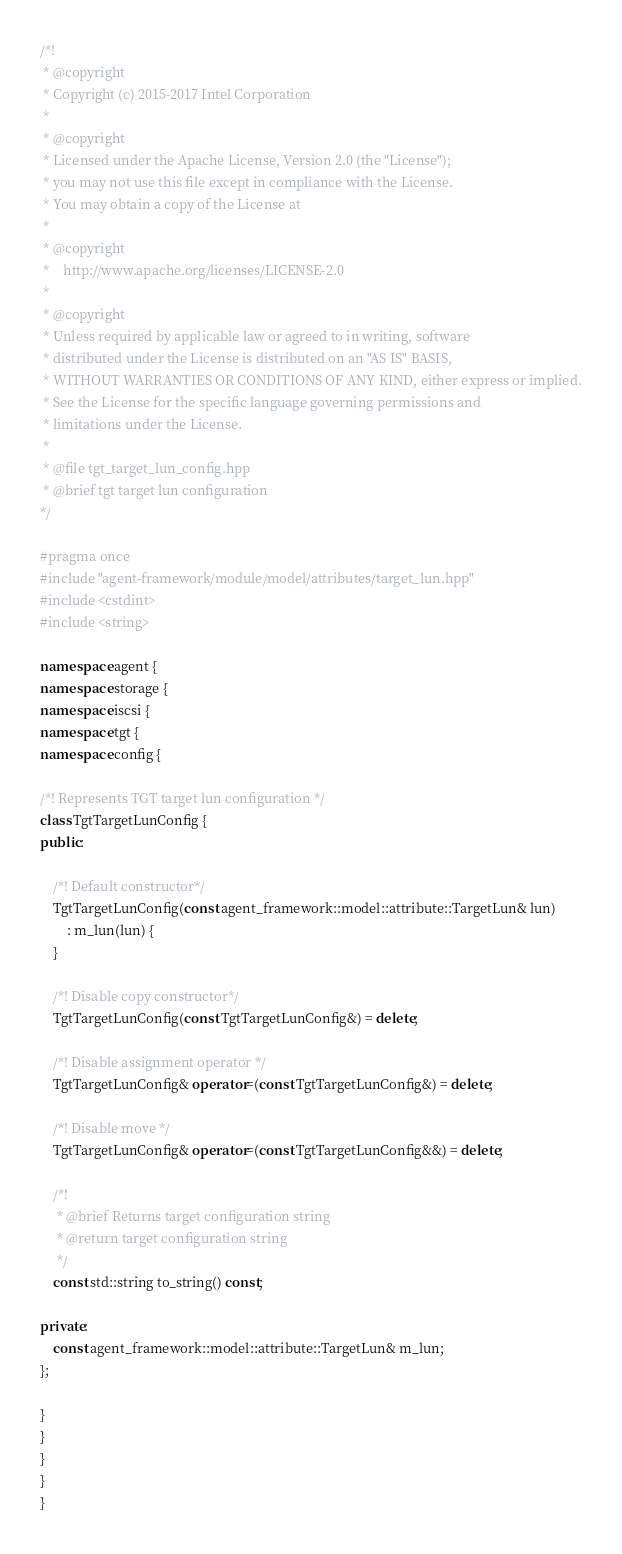Convert code to text. <code><loc_0><loc_0><loc_500><loc_500><_C++_>/*!
 * @copyright
 * Copyright (c) 2015-2017 Intel Corporation
 *
 * @copyright
 * Licensed under the Apache License, Version 2.0 (the "License");
 * you may not use this file except in compliance with the License.
 * You may obtain a copy of the License at
 *
 * @copyright
 *    http://www.apache.org/licenses/LICENSE-2.0
 *
 * @copyright
 * Unless required by applicable law or agreed to in writing, software
 * distributed under the License is distributed on an "AS IS" BASIS,
 * WITHOUT WARRANTIES OR CONDITIONS OF ANY KIND, either express or implied.
 * See the License for the specific language governing permissions and
 * limitations under the License.
 *
 * @file tgt_target_lun_config.hpp
 * @brief tgt target lun configuration
*/

#pragma once
#include "agent-framework/module/model/attributes/target_lun.hpp"
#include <cstdint>
#include <string>

namespace agent {
namespace storage {
namespace iscsi {
namespace tgt {
namespace config {

/*! Represents TGT target lun configuration */
class TgtTargetLunConfig {
public:

    /*! Default constructor*/
    TgtTargetLunConfig(const agent_framework::model::attribute::TargetLun& lun)
        : m_lun(lun) {
    }

    /*! Disable copy constructor*/
    TgtTargetLunConfig(const TgtTargetLunConfig&) = delete;

    /*! Disable assignment operator */
    TgtTargetLunConfig& operator=(const TgtTargetLunConfig&) = delete;

    /*! Disable move */
    TgtTargetLunConfig& operator=(const TgtTargetLunConfig&&) = delete;

    /*!
     * @brief Returns target configuration string
     * @return target configuration string
     */
    const std::string to_string() const;

private:
    const agent_framework::model::attribute::TargetLun& m_lun;
};

}
}
}
}
}


</code> 